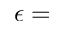<formula> <loc_0><loc_0><loc_500><loc_500>\epsilon =</formula> 